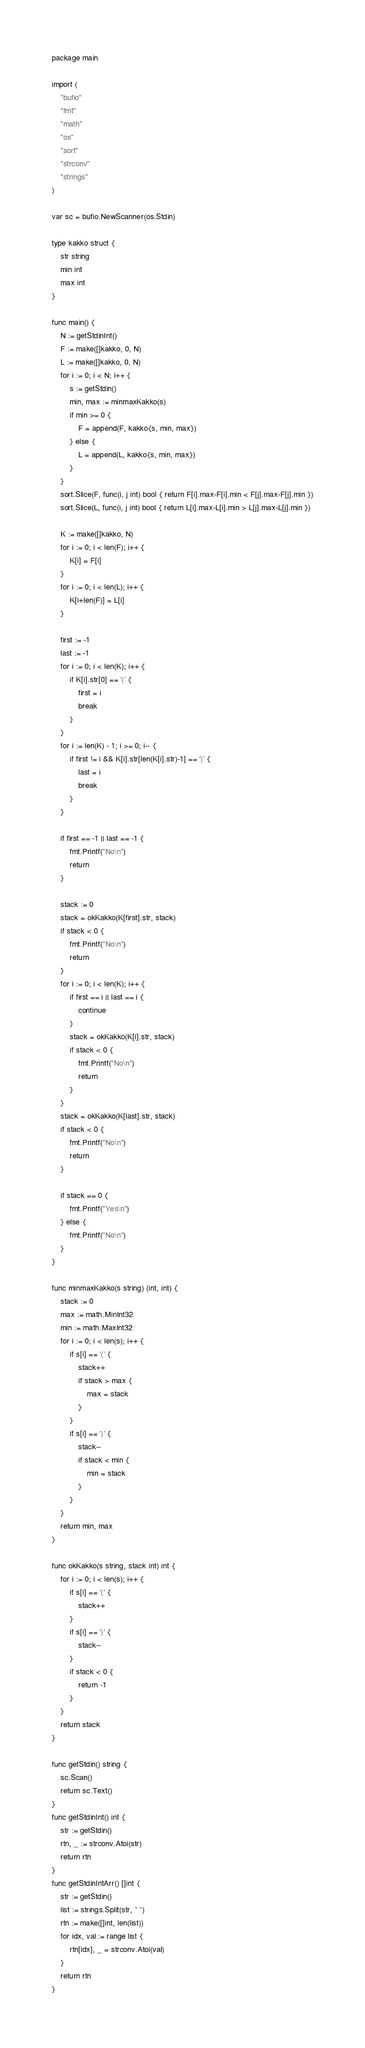Convert code to text. <code><loc_0><loc_0><loc_500><loc_500><_Go_>package main

import (
	"bufio"
	"fmt"
	"math"
	"os"
	"sort"
	"strconv"
	"strings"
)

var sc = bufio.NewScanner(os.Stdin)

type kakko struct {
	str string
	min int
	max int
}

func main() {
	N := getStdinInt()
	F := make([]kakko, 0, N)
	L := make([]kakko, 0, N)
	for i := 0; i < N; i++ {
		s := getStdin()
		min, max := minmaxKakko(s)
		if min >= 0 {
			F = append(F, kakko{s, min, max})
		} else {
			L = append(L, kakko{s, min, max})
		}
	}
	sort.Slice(F, func(i, j int) bool { return F[i].max-F[i].min < F[j].max-F[j].min })
	sort.Slice(L, func(i, j int) bool { return L[i].max-L[i].min > L[j].max-L[j].min })

	K := make([]kakko, N)
	for i := 0; i < len(F); i++ {
		K[i] = F[i]
	}
	for i := 0; i < len(L); i++ {
		K[i+len(F)] = L[i]
	}

	first := -1
	last := -1
	for i := 0; i < len(K); i++ {
		if K[i].str[0] == '(' {
			first = i
			break
		}
	}
	for i := len(K) - 1; i >= 0; i-- {
		if first != i && K[i].str[len(K[i].str)-1] == ')' {
			last = i
			break
		}
	}

	if first == -1 || last == -1 {
		fmt.Printf("No\n")
		return
	}

	stack := 0
	stack = okKakko(K[first].str, stack)
	if stack < 0 {
		fmt.Printf("No\n")
		return
	}
	for i := 0; i < len(K); i++ {
		if first == i || last == i {
			continue
		}
		stack = okKakko(K[i].str, stack)
		if stack < 0 {
			fmt.Printf("No\n")
			return
		}
	}
	stack = okKakko(K[last].str, stack)
	if stack < 0 {
		fmt.Printf("No\n")
		return
	}

	if stack == 0 {
		fmt.Printf("Yes\n")
	} else {
		fmt.Printf("No\n")
	}
}

func minmaxKakko(s string) (int, int) {
	stack := 0
	max := math.MinInt32
	min := math.MaxInt32
	for i := 0; i < len(s); i++ {
		if s[i] == '(' {
			stack++
			if stack > max {
				max = stack
			}
		}
		if s[i] == ')' {
			stack--
			if stack < min {
				min = stack
			}
		}
	}
	return min, max
}

func okKakko(s string, stack int) int {
	for i := 0; i < len(s); i++ {
		if s[i] == '(' {
			stack++
		}
		if s[i] == ')' {
			stack--
		}
		if stack < 0 {
			return -1
		}
	}
	return stack
}

func getStdin() string {
	sc.Scan()
	return sc.Text()
}
func getStdinInt() int {
	str := getStdin()
	rtn, _ := strconv.Atoi(str)
	return rtn
}
func getStdinIntArr() []int {
	str := getStdin()
	list := strings.Split(str, " ")
	rtn := make([]int, len(list))
	for idx, val := range list {
		rtn[idx], _ = strconv.Atoi(val)
	}
	return rtn
}
</code> 